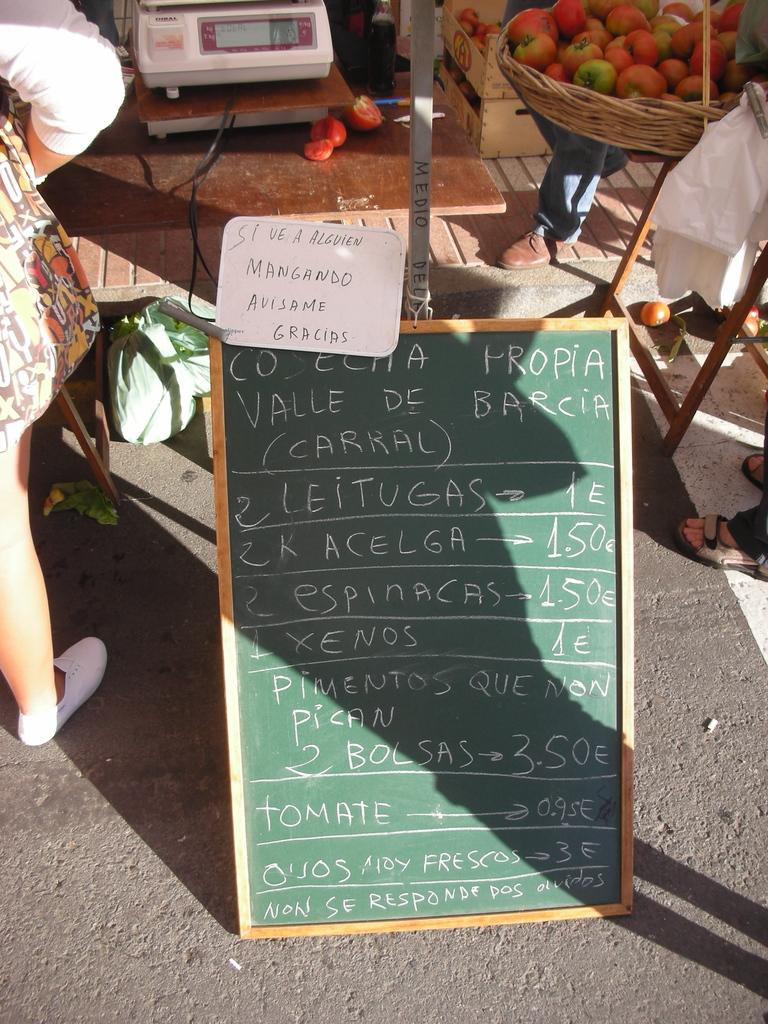What type of food can be seen in the image? There are tomatoes in the image. What object is present on the table in the image? There is an electronic weighing machine on a table in the image. What other items can be seen in the image besides tomatoes and the weighing machine? There are boards visible in the image. What country is depicted on the cast in the image? There is no cast present in the image, and therefore no country can be depicted on it. 